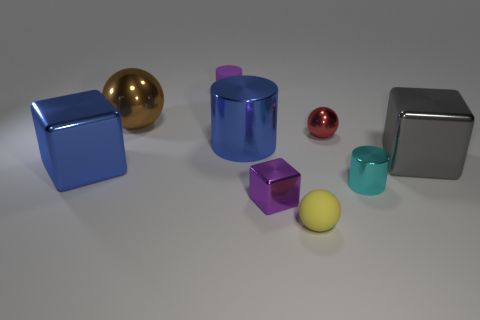What shape is the rubber object that is the same color as the tiny cube?
Offer a terse response. Cylinder. Is there anything else that is made of the same material as the gray cube?
Offer a very short reply. Yes. Do the rubber object that is behind the cyan thing and the cylinder that is to the right of the red shiny sphere have the same size?
Offer a very short reply. Yes. The sphere that is both right of the large brown ball and behind the tiny yellow sphere is made of what material?
Keep it short and to the point. Metal. Is there anything else that has the same color as the big metal cylinder?
Offer a terse response. Yes. Is the number of big shiny cylinders in front of the tiny rubber sphere less than the number of small green matte cubes?
Provide a succinct answer. No. Is the number of tiny things greater than the number of tiny red shiny spheres?
Make the answer very short. Yes. Is there a shiny thing to the left of the small cylinder that is left of the large blue metallic object right of the brown ball?
Give a very brief answer. Yes. How many other things are the same size as the yellow object?
Your answer should be very brief. 4. There is a tiny yellow ball; are there any small yellow balls left of it?
Your response must be concise. No. 